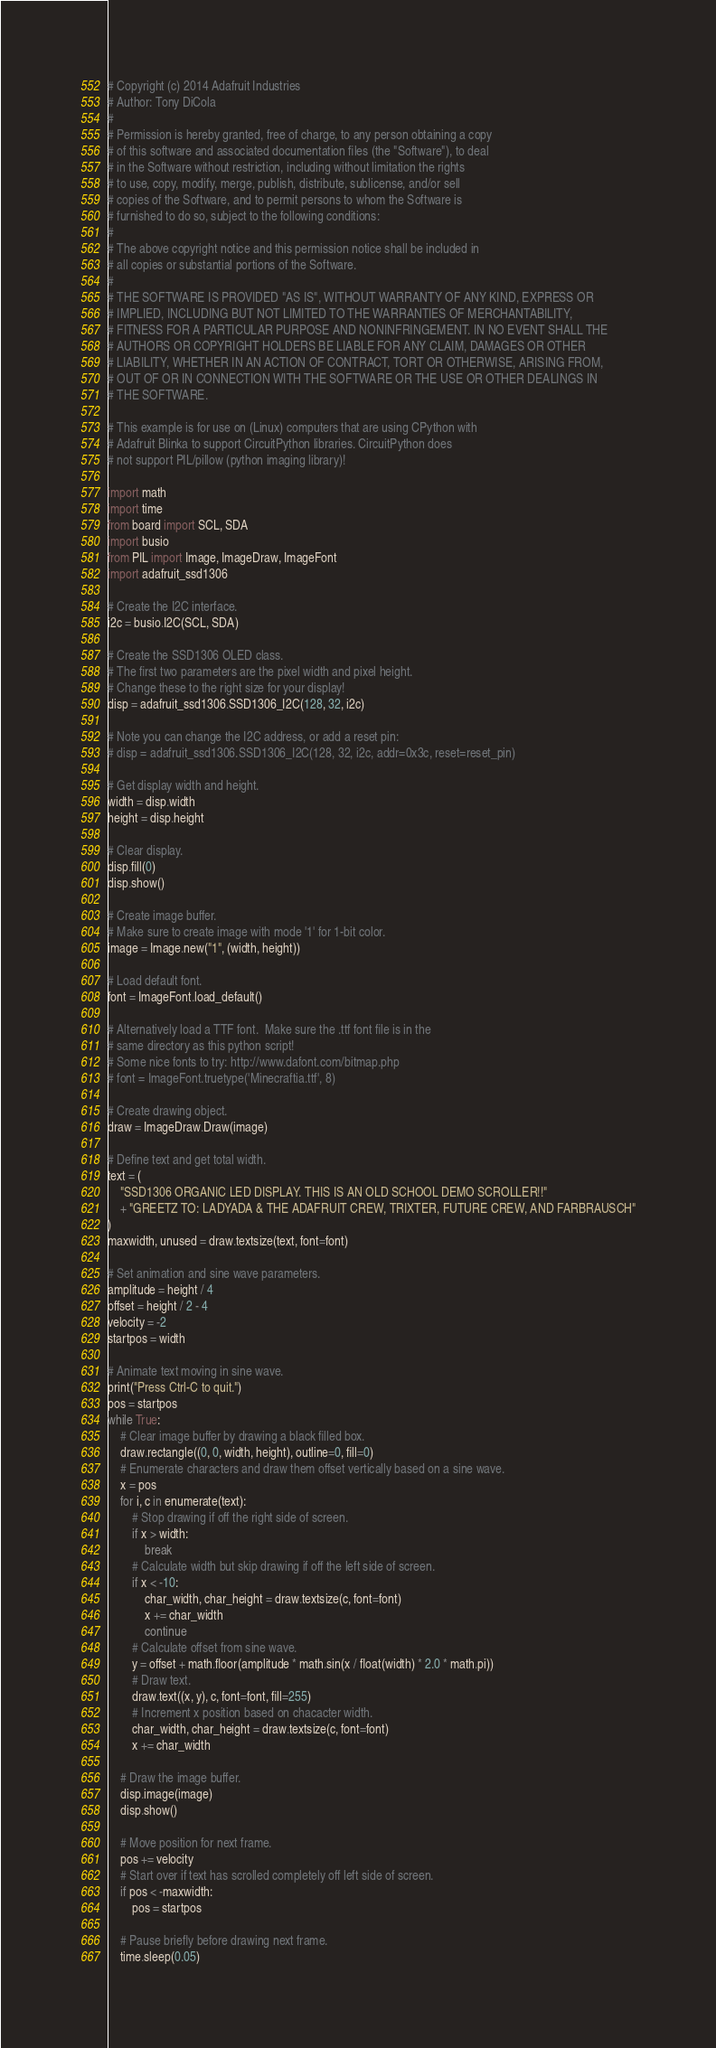<code> <loc_0><loc_0><loc_500><loc_500><_Python_># Copyright (c) 2014 Adafruit Industries
# Author: Tony DiCola
#
# Permission is hereby granted, free of charge, to any person obtaining a copy
# of this software and associated documentation files (the "Software"), to deal
# in the Software without restriction, including without limitation the rights
# to use, copy, modify, merge, publish, distribute, sublicense, and/or sell
# copies of the Software, and to permit persons to whom the Software is
# furnished to do so, subject to the following conditions:
#
# The above copyright notice and this permission notice shall be included in
# all copies or substantial portions of the Software.
#
# THE SOFTWARE IS PROVIDED "AS IS", WITHOUT WARRANTY OF ANY KIND, EXPRESS OR
# IMPLIED, INCLUDING BUT NOT LIMITED TO THE WARRANTIES OF MERCHANTABILITY,
# FITNESS FOR A PARTICULAR PURPOSE AND NONINFRINGEMENT. IN NO EVENT SHALL THE
# AUTHORS OR COPYRIGHT HOLDERS BE LIABLE FOR ANY CLAIM, DAMAGES OR OTHER
# LIABILITY, WHETHER IN AN ACTION OF CONTRACT, TORT OR OTHERWISE, ARISING FROM,
# OUT OF OR IN CONNECTION WITH THE SOFTWARE OR THE USE OR OTHER DEALINGS IN
# THE SOFTWARE.

# This example is for use on (Linux) computers that are using CPython with
# Adafruit Blinka to support CircuitPython libraries. CircuitPython does
# not support PIL/pillow (python imaging library)!

import math
import time
from board import SCL, SDA
import busio
from PIL import Image, ImageDraw, ImageFont
import adafruit_ssd1306

# Create the I2C interface.
i2c = busio.I2C(SCL, SDA)

# Create the SSD1306 OLED class.
# The first two parameters are the pixel width and pixel height.
# Change these to the right size for your display!
disp = adafruit_ssd1306.SSD1306_I2C(128, 32, i2c)

# Note you can change the I2C address, or add a reset pin:
# disp = adafruit_ssd1306.SSD1306_I2C(128, 32, i2c, addr=0x3c, reset=reset_pin)

# Get display width and height.
width = disp.width
height = disp.height

# Clear display.
disp.fill(0)
disp.show()

# Create image buffer.
# Make sure to create image with mode '1' for 1-bit color.
image = Image.new("1", (width, height))

# Load default font.
font = ImageFont.load_default()

# Alternatively load a TTF font.  Make sure the .ttf font file is in the
# same directory as this python script!
# Some nice fonts to try: http://www.dafont.com/bitmap.php
# font = ImageFont.truetype('Minecraftia.ttf', 8)

# Create drawing object.
draw = ImageDraw.Draw(image)

# Define text and get total width.
text = (
    "SSD1306 ORGANIC LED DISPLAY. THIS IS AN OLD SCHOOL DEMO SCROLLER!!"
    + "GREETZ TO: LADYADA & THE ADAFRUIT CREW, TRIXTER, FUTURE CREW, AND FARBRAUSCH"
)
maxwidth, unused = draw.textsize(text, font=font)

# Set animation and sine wave parameters.
amplitude = height / 4
offset = height / 2 - 4
velocity = -2
startpos = width

# Animate text moving in sine wave.
print("Press Ctrl-C to quit.")
pos = startpos
while True:
    # Clear image buffer by drawing a black filled box.
    draw.rectangle((0, 0, width, height), outline=0, fill=0)
    # Enumerate characters and draw them offset vertically based on a sine wave.
    x = pos
    for i, c in enumerate(text):
        # Stop drawing if off the right side of screen.
        if x > width:
            break
        # Calculate width but skip drawing if off the left side of screen.
        if x < -10:
            char_width, char_height = draw.textsize(c, font=font)
            x += char_width
            continue
        # Calculate offset from sine wave.
        y = offset + math.floor(amplitude * math.sin(x / float(width) * 2.0 * math.pi))
        # Draw text.
        draw.text((x, y), c, font=font, fill=255)
        # Increment x position based on chacacter width.
        char_width, char_height = draw.textsize(c, font=font)
        x += char_width

    # Draw the image buffer.
    disp.image(image)
    disp.show()

    # Move position for next frame.
    pos += velocity
    # Start over if text has scrolled completely off left side of screen.
    if pos < -maxwidth:
        pos = startpos

    # Pause briefly before drawing next frame.
    time.sleep(0.05)
</code> 